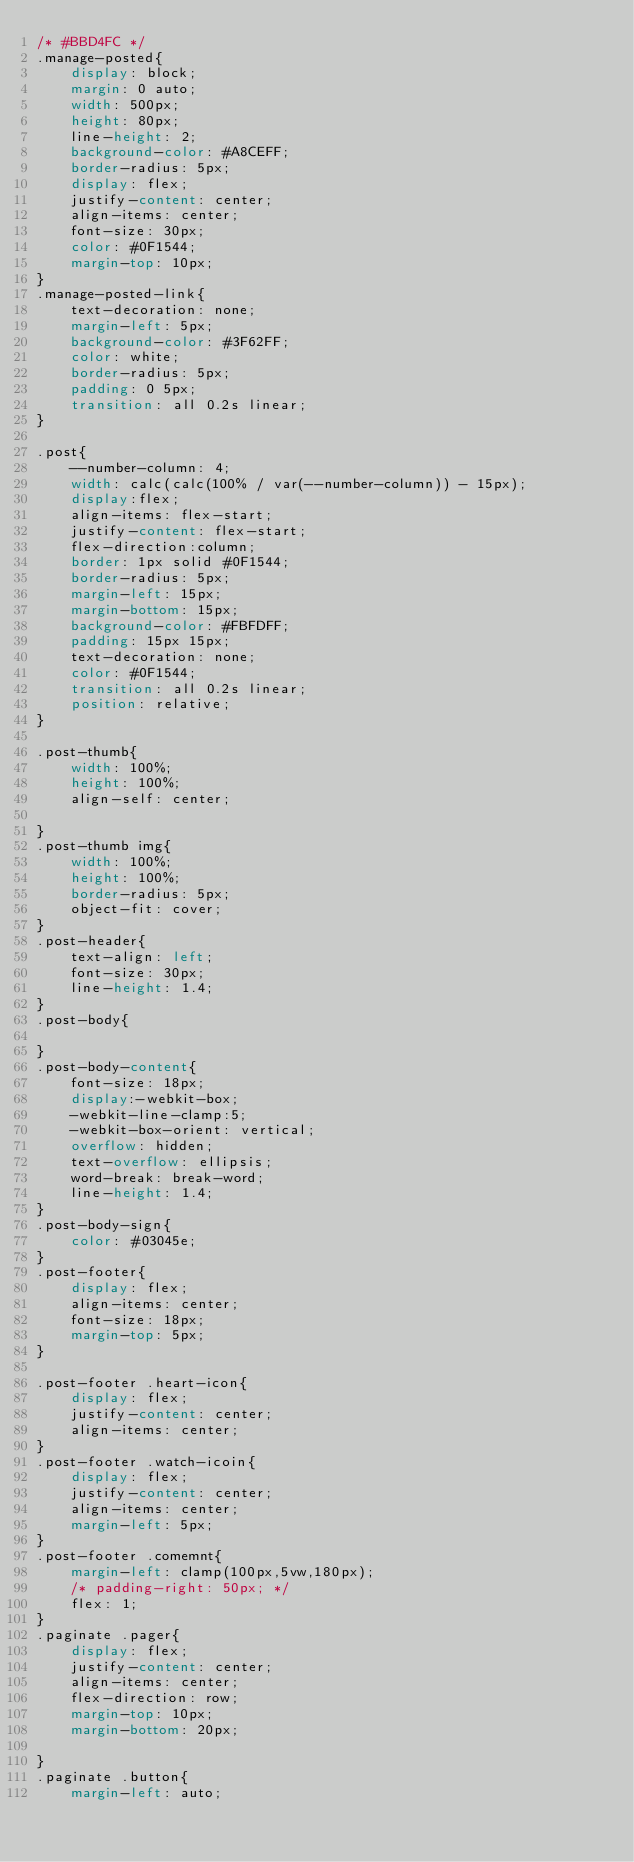Convert code to text. <code><loc_0><loc_0><loc_500><loc_500><_CSS_>/* #BBD4FC */
.manage-posted{
    display: block;
    margin: 0 auto;
    width: 500px;
    height: 80px;
    line-height: 2;
    background-color: #A8CEFF;
    border-radius: 5px;
    display: flex;
    justify-content: center;
    align-items: center;
    font-size: 30px;
    color: #0F1544;
    margin-top: 10px;
}
.manage-posted-link{
    text-decoration: none;
    margin-left: 5px;
    background-color: #3F62FF;
    color: white;
    border-radius: 5px;
    padding: 0 5px;
    transition: all 0.2s linear;
}

.post{
    --number-column: 4;
    width: calc(calc(100% / var(--number-column)) - 15px);
    display:flex;
    align-items: flex-start;
    justify-content: flex-start;
    flex-direction:column;
    border: 1px solid #0F1544;
    border-radius: 5px;
    margin-left: 15px;
    margin-bottom: 15px;
    background-color: #FBFDFF;
    padding: 15px 15px;
    text-decoration: none;
    color: #0F1544;
    transition: all 0.2s linear;
    position: relative;
}

.post-thumb{
    width: 100%;
    height: 100%;
    align-self: center;

}
.post-thumb img{
    width: 100%;
    height: 100%;
    border-radius: 5px;
    object-fit: cover;
}
.post-header{
    text-align: left;
    font-size: 30px;
    line-height: 1.4;
}
.post-body{

}
.post-body-content{
    font-size: 18px;
    display:-webkit-box;
    -webkit-line-clamp:5;
    -webkit-box-orient: vertical;
    overflow: hidden;
    text-overflow: ellipsis;
    word-break: break-word;
    line-height: 1.4;
}
.post-body-sign{
    color: #03045e;
}
.post-footer{
    display: flex;
    align-items: center;
    font-size: 18px;
    margin-top: 5px;
}

.post-footer .heart-icon{
    display: flex;
    justify-content: center;
    align-items: center;
}
.post-footer .watch-icoin{
    display: flex;
    justify-content: center;
    align-items: center;
    margin-left: 5px;
}
.post-footer .comemnt{
    margin-left: clamp(100px,5vw,180px);
    /* padding-right: 50px; */
    flex: 1;
}
.paginate .pager{
    display: flex;
    justify-content: center;
    align-items: center;
    flex-direction: row;
    margin-top: 10px;
    margin-bottom: 20px;

}
.paginate .button{
    margin-left: auto;</code> 